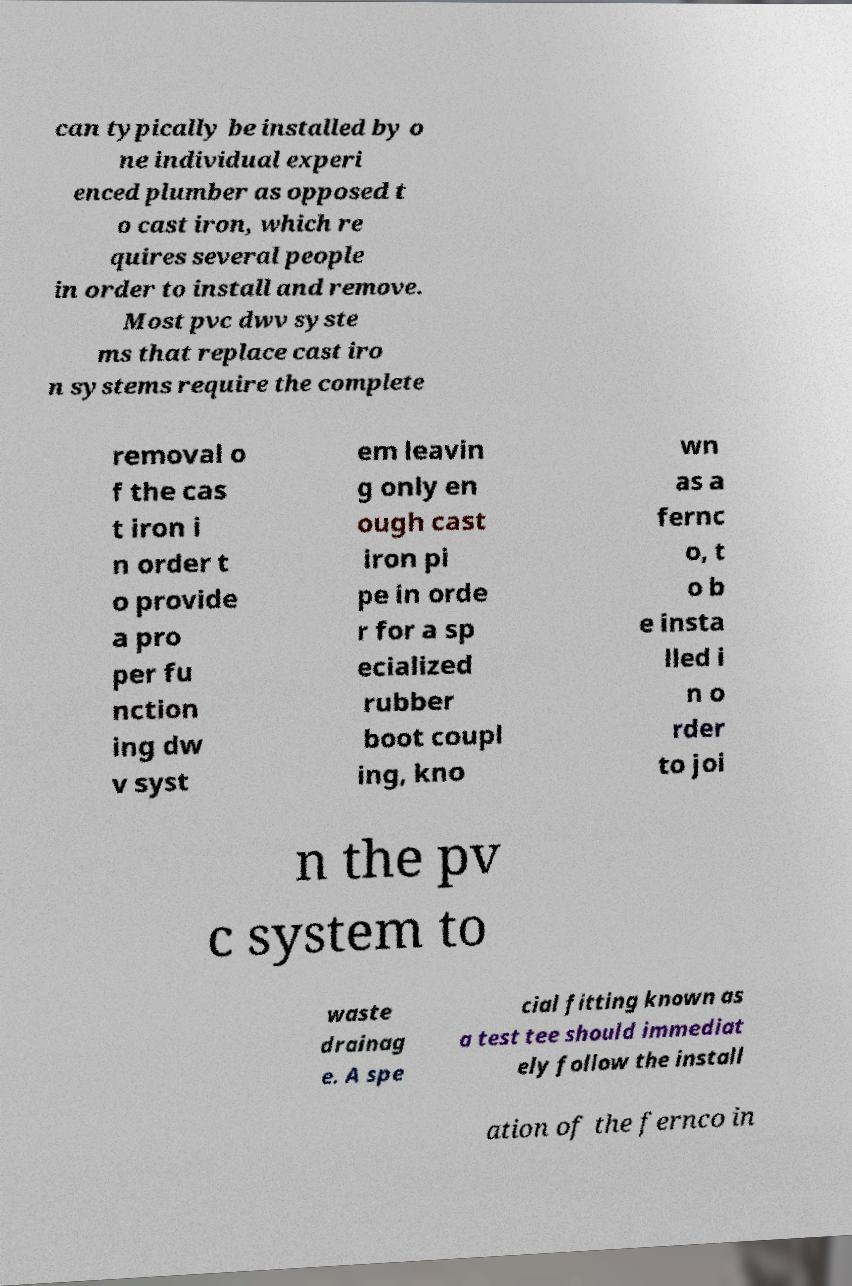Could you extract and type out the text from this image? can typically be installed by o ne individual experi enced plumber as opposed t o cast iron, which re quires several people in order to install and remove. Most pvc dwv syste ms that replace cast iro n systems require the complete removal o f the cas t iron i n order t o provide a pro per fu nction ing dw v syst em leavin g only en ough cast iron pi pe in orde r for a sp ecialized rubber boot coupl ing, kno wn as a fernc o, t o b e insta lled i n o rder to joi n the pv c system to waste drainag e. A spe cial fitting known as a test tee should immediat ely follow the install ation of the fernco in 